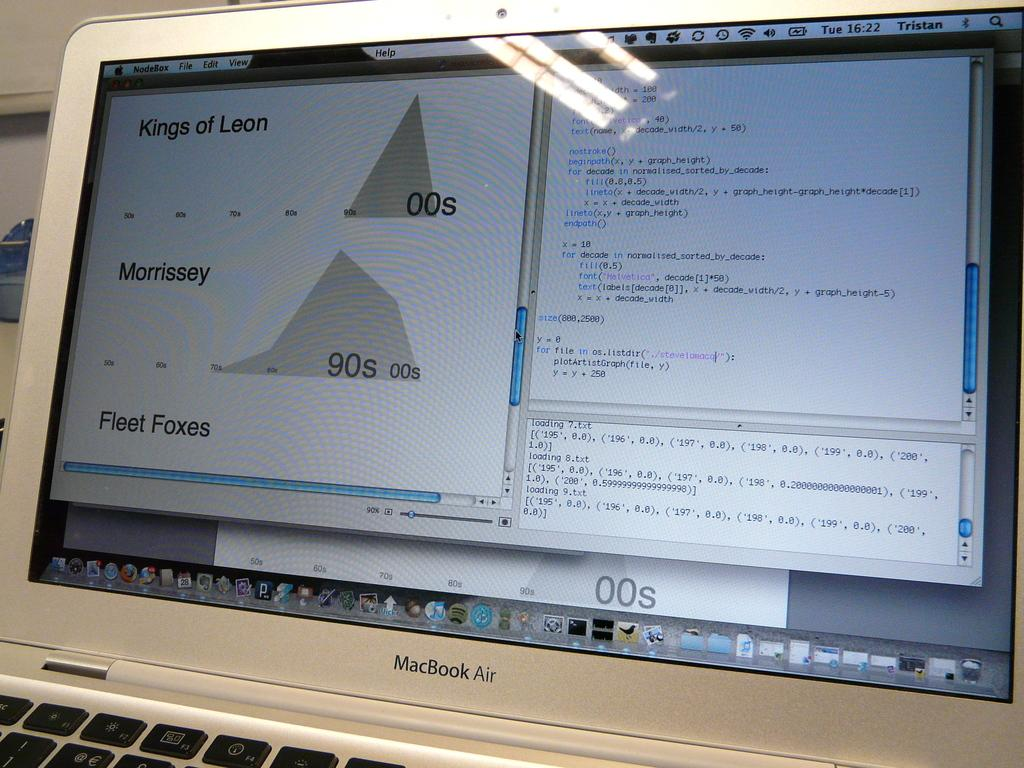<image>
Relay a brief, clear account of the picture shown. A Macbook Air laptop is open and the screen is on. 